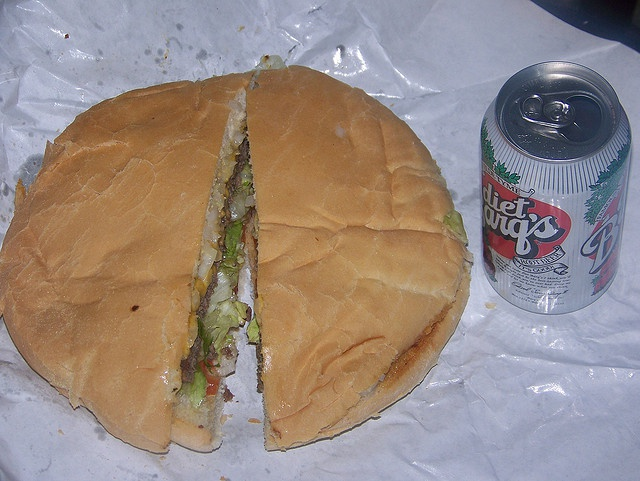Describe the objects in this image and their specific colors. I can see a sandwich in gray, tan, brown, and olive tones in this image. 